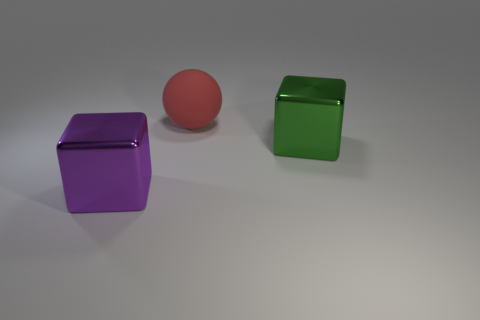There is a rubber sphere; are there any big shiny blocks to the right of it?
Your answer should be compact. Yes. There is a red matte object that is to the right of the object that is in front of the big metal cube that is on the right side of the ball; what is its size?
Ensure brevity in your answer.  Large. Is the shape of the big green thing in front of the big red sphere the same as the metal object in front of the green object?
Your answer should be compact. Yes. There is a purple metallic thing that is the same shape as the big green object; what is its size?
Make the answer very short. Large. What number of objects have the same material as the large green block?
Give a very brief answer. 1. What is the large green cube made of?
Your answer should be compact. Metal. What is the shape of the large thing behind the object that is on the right side of the large red ball?
Give a very brief answer. Sphere. There is a big object that is on the left side of the red matte sphere; what shape is it?
Ensure brevity in your answer.  Cube. What number of large metallic objects are the same color as the large rubber sphere?
Your answer should be compact. 0. What color is the large rubber thing?
Your answer should be very brief. Red. 